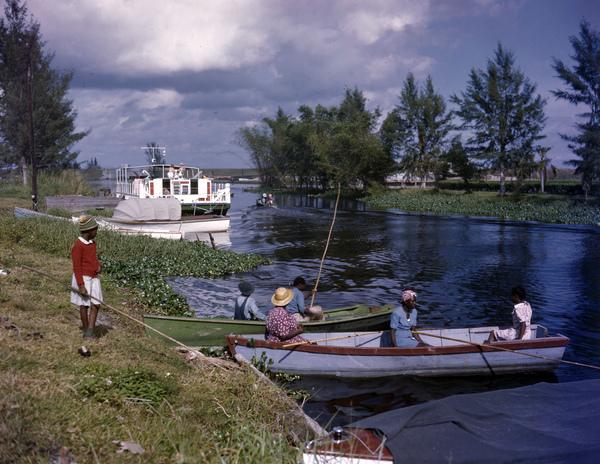Do any of the people in the photo appear over the age of 40?
Be succinct. Yes. Are these commercial fishing boats?
Write a very short answer. No. How many people are wearing head wraps?
Concise answer only. 1. How many boats in the water?
Short answer required. 4. 